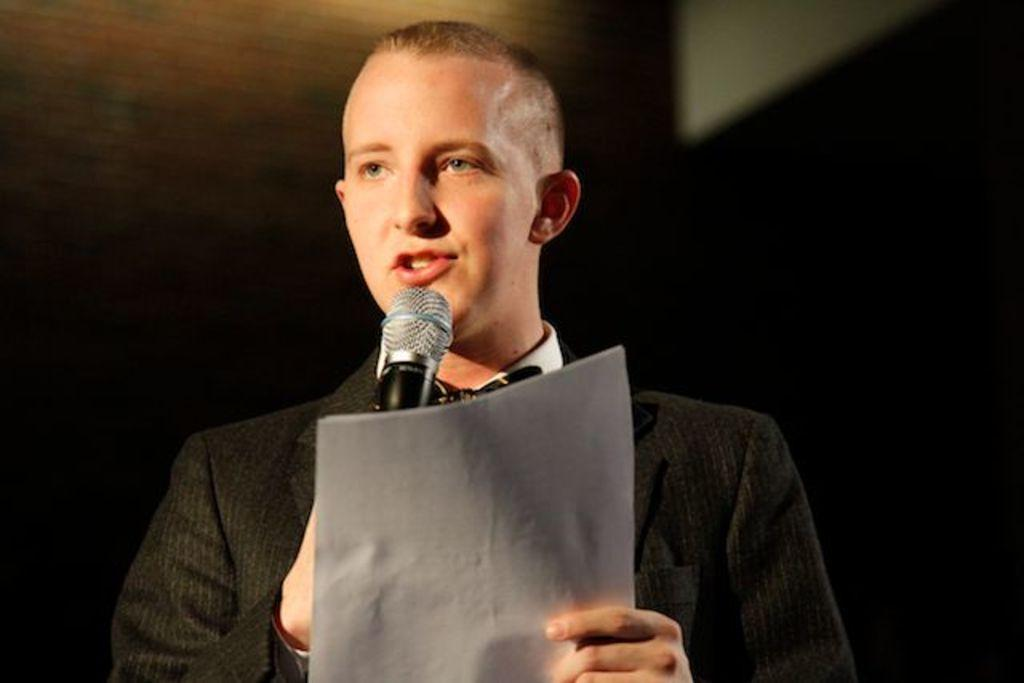What is the person in the image doing? The person is speaking in front of the image. What is the person wearing? The person is wearing a black suit. What is the person holding in one hand? The person is holding two papers in one hand. What is the person holding in the other hand? The person is holding a mic in the other hand. What type of scissors can be seen cutting the eggnog in the image? There are no scissors or eggnog present in the image. 